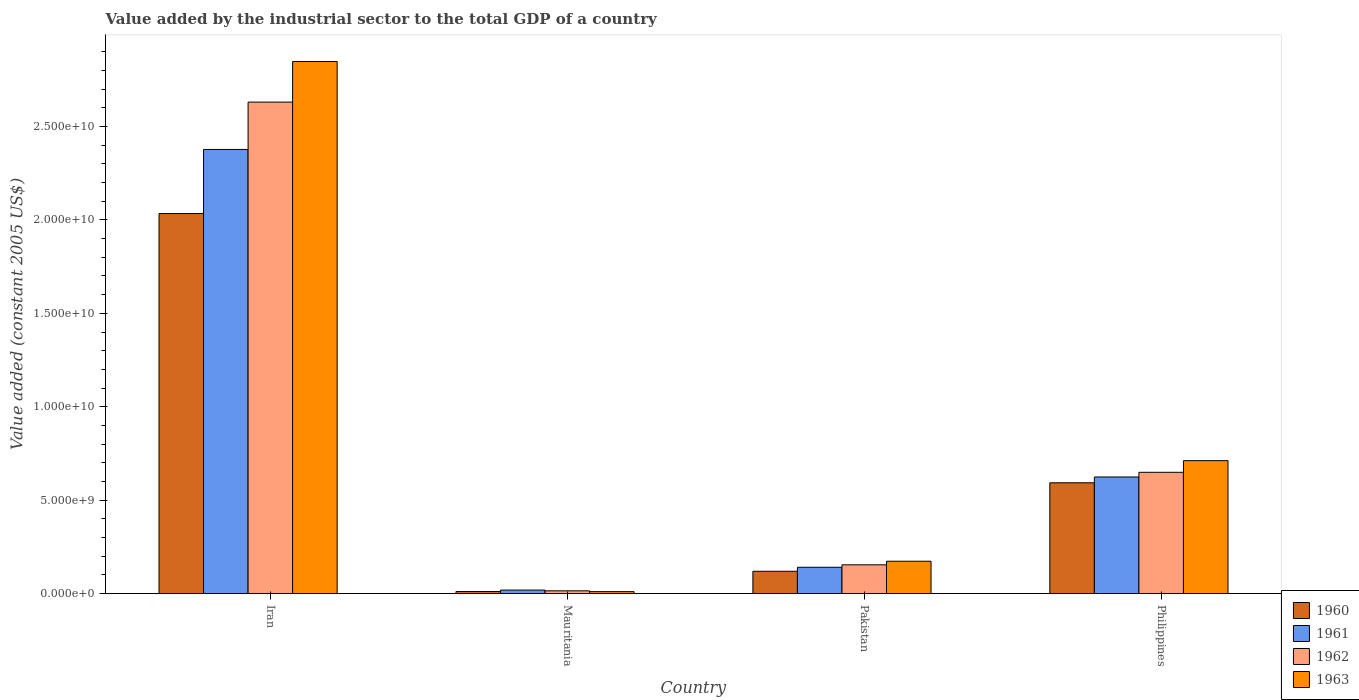How many different coloured bars are there?
Provide a succinct answer. 4. Are the number of bars per tick equal to the number of legend labels?
Offer a terse response. Yes. Are the number of bars on each tick of the X-axis equal?
Ensure brevity in your answer.  Yes. What is the label of the 1st group of bars from the left?
Give a very brief answer. Iran. In how many cases, is the number of bars for a given country not equal to the number of legend labels?
Offer a terse response. 0. What is the value added by the industrial sector in 1961 in Pakistan?
Ensure brevity in your answer.  1.41e+09. Across all countries, what is the maximum value added by the industrial sector in 1960?
Keep it short and to the point. 2.03e+1. Across all countries, what is the minimum value added by the industrial sector in 1961?
Your response must be concise. 1.92e+08. In which country was the value added by the industrial sector in 1963 maximum?
Offer a terse response. Iran. In which country was the value added by the industrial sector in 1961 minimum?
Offer a terse response. Mauritania. What is the total value added by the industrial sector in 1963 in the graph?
Provide a succinct answer. 3.74e+1. What is the difference between the value added by the industrial sector in 1960 in Iran and that in Pakistan?
Your response must be concise. 1.91e+1. What is the difference between the value added by the industrial sector in 1962 in Iran and the value added by the industrial sector in 1960 in Philippines?
Offer a terse response. 2.04e+1. What is the average value added by the industrial sector in 1961 per country?
Ensure brevity in your answer.  7.90e+09. What is the difference between the value added by the industrial sector of/in 1961 and value added by the industrial sector of/in 1963 in Mauritania?
Provide a succinct answer. 8.39e+07. In how many countries, is the value added by the industrial sector in 1961 greater than 9000000000 US$?
Provide a succinct answer. 1. What is the ratio of the value added by the industrial sector in 1962 in Iran to that in Pakistan?
Your response must be concise. 17.04. Is the value added by the industrial sector in 1963 in Mauritania less than that in Philippines?
Provide a short and direct response. Yes. What is the difference between the highest and the second highest value added by the industrial sector in 1962?
Make the answer very short. -1.98e+1. What is the difference between the highest and the lowest value added by the industrial sector in 1962?
Give a very brief answer. 2.62e+1. Is it the case that in every country, the sum of the value added by the industrial sector in 1962 and value added by the industrial sector in 1963 is greater than the sum of value added by the industrial sector in 1960 and value added by the industrial sector in 1961?
Offer a terse response. No. What does the 4th bar from the left in Philippines represents?
Your answer should be compact. 1963. How many bars are there?
Keep it short and to the point. 16. Are all the bars in the graph horizontal?
Provide a succinct answer. No. What is the difference between two consecutive major ticks on the Y-axis?
Keep it short and to the point. 5.00e+09. Does the graph contain any zero values?
Your answer should be compact. No. Does the graph contain grids?
Provide a succinct answer. No. Where does the legend appear in the graph?
Ensure brevity in your answer.  Bottom right. How many legend labels are there?
Your answer should be very brief. 4. What is the title of the graph?
Make the answer very short. Value added by the industrial sector to the total GDP of a country. What is the label or title of the Y-axis?
Give a very brief answer. Value added (constant 2005 US$). What is the Value added (constant 2005 US$) of 1960 in Iran?
Provide a short and direct response. 2.03e+1. What is the Value added (constant 2005 US$) in 1961 in Iran?
Your response must be concise. 2.38e+1. What is the Value added (constant 2005 US$) in 1962 in Iran?
Offer a very short reply. 2.63e+1. What is the Value added (constant 2005 US$) in 1963 in Iran?
Ensure brevity in your answer.  2.85e+1. What is the Value added (constant 2005 US$) of 1960 in Mauritania?
Offer a very short reply. 1.15e+08. What is the Value added (constant 2005 US$) in 1961 in Mauritania?
Provide a short and direct response. 1.92e+08. What is the Value added (constant 2005 US$) of 1962 in Mauritania?
Your response must be concise. 1.51e+08. What is the Value added (constant 2005 US$) of 1963 in Mauritania?
Provide a succinct answer. 1.08e+08. What is the Value added (constant 2005 US$) in 1960 in Pakistan?
Offer a very short reply. 1.20e+09. What is the Value added (constant 2005 US$) of 1961 in Pakistan?
Provide a succinct answer. 1.41e+09. What is the Value added (constant 2005 US$) of 1962 in Pakistan?
Your answer should be very brief. 1.54e+09. What is the Value added (constant 2005 US$) of 1963 in Pakistan?
Provide a succinct answer. 1.74e+09. What is the Value added (constant 2005 US$) in 1960 in Philippines?
Your answer should be very brief. 5.93e+09. What is the Value added (constant 2005 US$) of 1961 in Philippines?
Keep it short and to the point. 6.24e+09. What is the Value added (constant 2005 US$) of 1962 in Philippines?
Your answer should be compact. 6.49e+09. What is the Value added (constant 2005 US$) in 1963 in Philippines?
Keep it short and to the point. 7.12e+09. Across all countries, what is the maximum Value added (constant 2005 US$) in 1960?
Offer a very short reply. 2.03e+1. Across all countries, what is the maximum Value added (constant 2005 US$) in 1961?
Offer a very short reply. 2.38e+1. Across all countries, what is the maximum Value added (constant 2005 US$) of 1962?
Offer a very short reply. 2.63e+1. Across all countries, what is the maximum Value added (constant 2005 US$) in 1963?
Your answer should be very brief. 2.85e+1. Across all countries, what is the minimum Value added (constant 2005 US$) of 1960?
Provide a succinct answer. 1.15e+08. Across all countries, what is the minimum Value added (constant 2005 US$) of 1961?
Offer a very short reply. 1.92e+08. Across all countries, what is the minimum Value added (constant 2005 US$) of 1962?
Ensure brevity in your answer.  1.51e+08. Across all countries, what is the minimum Value added (constant 2005 US$) in 1963?
Make the answer very short. 1.08e+08. What is the total Value added (constant 2005 US$) in 1960 in the graph?
Provide a short and direct response. 2.76e+1. What is the total Value added (constant 2005 US$) in 1961 in the graph?
Your answer should be compact. 3.16e+1. What is the total Value added (constant 2005 US$) of 1962 in the graph?
Provide a short and direct response. 3.45e+1. What is the total Value added (constant 2005 US$) in 1963 in the graph?
Give a very brief answer. 3.74e+1. What is the difference between the Value added (constant 2005 US$) in 1960 in Iran and that in Mauritania?
Offer a very short reply. 2.02e+1. What is the difference between the Value added (constant 2005 US$) in 1961 in Iran and that in Mauritania?
Offer a very short reply. 2.36e+1. What is the difference between the Value added (constant 2005 US$) in 1962 in Iran and that in Mauritania?
Offer a terse response. 2.62e+1. What is the difference between the Value added (constant 2005 US$) of 1963 in Iran and that in Mauritania?
Your response must be concise. 2.84e+1. What is the difference between the Value added (constant 2005 US$) of 1960 in Iran and that in Pakistan?
Ensure brevity in your answer.  1.91e+1. What is the difference between the Value added (constant 2005 US$) of 1961 in Iran and that in Pakistan?
Your answer should be compact. 2.24e+1. What is the difference between the Value added (constant 2005 US$) of 1962 in Iran and that in Pakistan?
Ensure brevity in your answer.  2.48e+1. What is the difference between the Value added (constant 2005 US$) of 1963 in Iran and that in Pakistan?
Give a very brief answer. 2.67e+1. What is the difference between the Value added (constant 2005 US$) of 1960 in Iran and that in Philippines?
Make the answer very short. 1.44e+1. What is the difference between the Value added (constant 2005 US$) of 1961 in Iran and that in Philippines?
Offer a terse response. 1.75e+1. What is the difference between the Value added (constant 2005 US$) in 1962 in Iran and that in Philippines?
Give a very brief answer. 1.98e+1. What is the difference between the Value added (constant 2005 US$) of 1963 in Iran and that in Philippines?
Your answer should be compact. 2.14e+1. What is the difference between the Value added (constant 2005 US$) of 1960 in Mauritania and that in Pakistan?
Offer a very short reply. -1.08e+09. What is the difference between the Value added (constant 2005 US$) in 1961 in Mauritania and that in Pakistan?
Your answer should be very brief. -1.22e+09. What is the difference between the Value added (constant 2005 US$) in 1962 in Mauritania and that in Pakistan?
Your answer should be compact. -1.39e+09. What is the difference between the Value added (constant 2005 US$) of 1963 in Mauritania and that in Pakistan?
Your answer should be compact. -1.63e+09. What is the difference between the Value added (constant 2005 US$) in 1960 in Mauritania and that in Philippines?
Offer a terse response. -5.82e+09. What is the difference between the Value added (constant 2005 US$) in 1961 in Mauritania and that in Philippines?
Your answer should be very brief. -6.05e+09. What is the difference between the Value added (constant 2005 US$) in 1962 in Mauritania and that in Philippines?
Your response must be concise. -6.34e+09. What is the difference between the Value added (constant 2005 US$) in 1963 in Mauritania and that in Philippines?
Keep it short and to the point. -7.01e+09. What is the difference between the Value added (constant 2005 US$) in 1960 in Pakistan and that in Philippines?
Offer a terse response. -4.73e+09. What is the difference between the Value added (constant 2005 US$) in 1961 in Pakistan and that in Philippines?
Offer a very short reply. -4.83e+09. What is the difference between the Value added (constant 2005 US$) in 1962 in Pakistan and that in Philippines?
Ensure brevity in your answer.  -4.95e+09. What is the difference between the Value added (constant 2005 US$) of 1963 in Pakistan and that in Philippines?
Give a very brief answer. -5.38e+09. What is the difference between the Value added (constant 2005 US$) in 1960 in Iran and the Value added (constant 2005 US$) in 1961 in Mauritania?
Provide a short and direct response. 2.01e+1. What is the difference between the Value added (constant 2005 US$) in 1960 in Iran and the Value added (constant 2005 US$) in 1962 in Mauritania?
Provide a short and direct response. 2.02e+1. What is the difference between the Value added (constant 2005 US$) of 1960 in Iran and the Value added (constant 2005 US$) of 1963 in Mauritania?
Provide a short and direct response. 2.02e+1. What is the difference between the Value added (constant 2005 US$) in 1961 in Iran and the Value added (constant 2005 US$) in 1962 in Mauritania?
Provide a short and direct response. 2.36e+1. What is the difference between the Value added (constant 2005 US$) in 1961 in Iran and the Value added (constant 2005 US$) in 1963 in Mauritania?
Give a very brief answer. 2.37e+1. What is the difference between the Value added (constant 2005 US$) in 1962 in Iran and the Value added (constant 2005 US$) in 1963 in Mauritania?
Provide a succinct answer. 2.62e+1. What is the difference between the Value added (constant 2005 US$) in 1960 in Iran and the Value added (constant 2005 US$) in 1961 in Pakistan?
Ensure brevity in your answer.  1.89e+1. What is the difference between the Value added (constant 2005 US$) in 1960 in Iran and the Value added (constant 2005 US$) in 1962 in Pakistan?
Keep it short and to the point. 1.88e+1. What is the difference between the Value added (constant 2005 US$) of 1960 in Iran and the Value added (constant 2005 US$) of 1963 in Pakistan?
Your answer should be compact. 1.86e+1. What is the difference between the Value added (constant 2005 US$) of 1961 in Iran and the Value added (constant 2005 US$) of 1962 in Pakistan?
Your response must be concise. 2.22e+1. What is the difference between the Value added (constant 2005 US$) of 1961 in Iran and the Value added (constant 2005 US$) of 1963 in Pakistan?
Keep it short and to the point. 2.20e+1. What is the difference between the Value added (constant 2005 US$) in 1962 in Iran and the Value added (constant 2005 US$) in 1963 in Pakistan?
Provide a short and direct response. 2.46e+1. What is the difference between the Value added (constant 2005 US$) in 1960 in Iran and the Value added (constant 2005 US$) in 1961 in Philippines?
Offer a terse response. 1.41e+1. What is the difference between the Value added (constant 2005 US$) in 1960 in Iran and the Value added (constant 2005 US$) in 1962 in Philippines?
Your response must be concise. 1.38e+1. What is the difference between the Value added (constant 2005 US$) in 1960 in Iran and the Value added (constant 2005 US$) in 1963 in Philippines?
Your answer should be compact. 1.32e+1. What is the difference between the Value added (constant 2005 US$) in 1961 in Iran and the Value added (constant 2005 US$) in 1962 in Philippines?
Keep it short and to the point. 1.73e+1. What is the difference between the Value added (constant 2005 US$) of 1961 in Iran and the Value added (constant 2005 US$) of 1963 in Philippines?
Offer a very short reply. 1.67e+1. What is the difference between the Value added (constant 2005 US$) in 1962 in Iran and the Value added (constant 2005 US$) in 1963 in Philippines?
Ensure brevity in your answer.  1.92e+1. What is the difference between the Value added (constant 2005 US$) of 1960 in Mauritania and the Value added (constant 2005 US$) of 1961 in Pakistan?
Your answer should be compact. -1.30e+09. What is the difference between the Value added (constant 2005 US$) in 1960 in Mauritania and the Value added (constant 2005 US$) in 1962 in Pakistan?
Ensure brevity in your answer.  -1.43e+09. What is the difference between the Value added (constant 2005 US$) of 1960 in Mauritania and the Value added (constant 2005 US$) of 1963 in Pakistan?
Your answer should be compact. -1.62e+09. What is the difference between the Value added (constant 2005 US$) of 1961 in Mauritania and the Value added (constant 2005 US$) of 1962 in Pakistan?
Ensure brevity in your answer.  -1.35e+09. What is the difference between the Value added (constant 2005 US$) of 1961 in Mauritania and the Value added (constant 2005 US$) of 1963 in Pakistan?
Your answer should be compact. -1.54e+09. What is the difference between the Value added (constant 2005 US$) in 1962 in Mauritania and the Value added (constant 2005 US$) in 1963 in Pakistan?
Make the answer very short. -1.58e+09. What is the difference between the Value added (constant 2005 US$) in 1960 in Mauritania and the Value added (constant 2005 US$) in 1961 in Philippines?
Make the answer very short. -6.13e+09. What is the difference between the Value added (constant 2005 US$) of 1960 in Mauritania and the Value added (constant 2005 US$) of 1962 in Philippines?
Provide a succinct answer. -6.38e+09. What is the difference between the Value added (constant 2005 US$) of 1960 in Mauritania and the Value added (constant 2005 US$) of 1963 in Philippines?
Provide a succinct answer. -7.00e+09. What is the difference between the Value added (constant 2005 US$) of 1961 in Mauritania and the Value added (constant 2005 US$) of 1962 in Philippines?
Your answer should be very brief. -6.30e+09. What is the difference between the Value added (constant 2005 US$) of 1961 in Mauritania and the Value added (constant 2005 US$) of 1963 in Philippines?
Make the answer very short. -6.93e+09. What is the difference between the Value added (constant 2005 US$) of 1962 in Mauritania and the Value added (constant 2005 US$) of 1963 in Philippines?
Ensure brevity in your answer.  -6.97e+09. What is the difference between the Value added (constant 2005 US$) of 1960 in Pakistan and the Value added (constant 2005 US$) of 1961 in Philippines?
Provide a succinct answer. -5.05e+09. What is the difference between the Value added (constant 2005 US$) in 1960 in Pakistan and the Value added (constant 2005 US$) in 1962 in Philippines?
Your answer should be compact. -5.30e+09. What is the difference between the Value added (constant 2005 US$) in 1960 in Pakistan and the Value added (constant 2005 US$) in 1963 in Philippines?
Your answer should be compact. -5.92e+09. What is the difference between the Value added (constant 2005 US$) of 1961 in Pakistan and the Value added (constant 2005 US$) of 1962 in Philippines?
Make the answer very short. -5.08e+09. What is the difference between the Value added (constant 2005 US$) in 1961 in Pakistan and the Value added (constant 2005 US$) in 1963 in Philippines?
Give a very brief answer. -5.71e+09. What is the difference between the Value added (constant 2005 US$) in 1962 in Pakistan and the Value added (constant 2005 US$) in 1963 in Philippines?
Offer a very short reply. -5.57e+09. What is the average Value added (constant 2005 US$) in 1960 per country?
Keep it short and to the point. 6.90e+09. What is the average Value added (constant 2005 US$) of 1961 per country?
Provide a succinct answer. 7.90e+09. What is the average Value added (constant 2005 US$) in 1962 per country?
Give a very brief answer. 8.62e+09. What is the average Value added (constant 2005 US$) in 1963 per country?
Ensure brevity in your answer.  9.36e+09. What is the difference between the Value added (constant 2005 US$) in 1960 and Value added (constant 2005 US$) in 1961 in Iran?
Give a very brief answer. -3.43e+09. What is the difference between the Value added (constant 2005 US$) in 1960 and Value added (constant 2005 US$) in 1962 in Iran?
Give a very brief answer. -5.96e+09. What is the difference between the Value added (constant 2005 US$) of 1960 and Value added (constant 2005 US$) of 1963 in Iran?
Your answer should be compact. -8.14e+09. What is the difference between the Value added (constant 2005 US$) of 1961 and Value added (constant 2005 US$) of 1962 in Iran?
Your response must be concise. -2.53e+09. What is the difference between the Value added (constant 2005 US$) of 1961 and Value added (constant 2005 US$) of 1963 in Iran?
Offer a terse response. -4.71e+09. What is the difference between the Value added (constant 2005 US$) in 1962 and Value added (constant 2005 US$) in 1963 in Iran?
Keep it short and to the point. -2.17e+09. What is the difference between the Value added (constant 2005 US$) in 1960 and Value added (constant 2005 US$) in 1961 in Mauritania?
Keep it short and to the point. -7.68e+07. What is the difference between the Value added (constant 2005 US$) of 1960 and Value added (constant 2005 US$) of 1962 in Mauritania?
Ensure brevity in your answer.  -3.59e+07. What is the difference between the Value added (constant 2005 US$) of 1960 and Value added (constant 2005 US$) of 1963 in Mauritania?
Your response must be concise. 7.13e+06. What is the difference between the Value added (constant 2005 US$) in 1961 and Value added (constant 2005 US$) in 1962 in Mauritania?
Ensure brevity in your answer.  4.09e+07. What is the difference between the Value added (constant 2005 US$) of 1961 and Value added (constant 2005 US$) of 1963 in Mauritania?
Provide a succinct answer. 8.39e+07. What is the difference between the Value added (constant 2005 US$) of 1962 and Value added (constant 2005 US$) of 1963 in Mauritania?
Offer a terse response. 4.31e+07. What is the difference between the Value added (constant 2005 US$) in 1960 and Value added (constant 2005 US$) in 1961 in Pakistan?
Offer a terse response. -2.14e+08. What is the difference between the Value added (constant 2005 US$) in 1960 and Value added (constant 2005 US$) in 1962 in Pakistan?
Keep it short and to the point. -3.45e+08. What is the difference between the Value added (constant 2005 US$) of 1960 and Value added (constant 2005 US$) of 1963 in Pakistan?
Keep it short and to the point. -5.37e+08. What is the difference between the Value added (constant 2005 US$) in 1961 and Value added (constant 2005 US$) in 1962 in Pakistan?
Your answer should be very brief. -1.32e+08. What is the difference between the Value added (constant 2005 US$) in 1961 and Value added (constant 2005 US$) in 1963 in Pakistan?
Give a very brief answer. -3.23e+08. What is the difference between the Value added (constant 2005 US$) in 1962 and Value added (constant 2005 US$) in 1963 in Pakistan?
Your answer should be compact. -1.92e+08. What is the difference between the Value added (constant 2005 US$) in 1960 and Value added (constant 2005 US$) in 1961 in Philippines?
Your answer should be compact. -3.11e+08. What is the difference between the Value added (constant 2005 US$) in 1960 and Value added (constant 2005 US$) in 1962 in Philippines?
Your response must be concise. -5.61e+08. What is the difference between the Value added (constant 2005 US$) of 1960 and Value added (constant 2005 US$) of 1963 in Philippines?
Keep it short and to the point. -1.18e+09. What is the difference between the Value added (constant 2005 US$) in 1961 and Value added (constant 2005 US$) in 1962 in Philippines?
Provide a short and direct response. -2.50e+08. What is the difference between the Value added (constant 2005 US$) in 1961 and Value added (constant 2005 US$) in 1963 in Philippines?
Provide a succinct answer. -8.74e+08. What is the difference between the Value added (constant 2005 US$) in 1962 and Value added (constant 2005 US$) in 1963 in Philippines?
Your answer should be very brief. -6.24e+08. What is the ratio of the Value added (constant 2005 US$) in 1960 in Iran to that in Mauritania?
Keep it short and to the point. 176.32. What is the ratio of the Value added (constant 2005 US$) in 1961 in Iran to that in Mauritania?
Keep it short and to the point. 123.7. What is the ratio of the Value added (constant 2005 US$) in 1962 in Iran to that in Mauritania?
Offer a very short reply. 173.84. What is the ratio of the Value added (constant 2005 US$) of 1963 in Iran to that in Mauritania?
Ensure brevity in your answer.  263.11. What is the ratio of the Value added (constant 2005 US$) in 1960 in Iran to that in Pakistan?
Provide a succinct answer. 16.98. What is the ratio of the Value added (constant 2005 US$) in 1961 in Iran to that in Pakistan?
Give a very brief answer. 16.84. What is the ratio of the Value added (constant 2005 US$) in 1962 in Iran to that in Pakistan?
Your answer should be compact. 17.04. What is the ratio of the Value added (constant 2005 US$) in 1963 in Iran to that in Pakistan?
Your answer should be very brief. 16.41. What is the ratio of the Value added (constant 2005 US$) of 1960 in Iran to that in Philippines?
Ensure brevity in your answer.  3.43. What is the ratio of the Value added (constant 2005 US$) in 1961 in Iran to that in Philippines?
Ensure brevity in your answer.  3.81. What is the ratio of the Value added (constant 2005 US$) in 1962 in Iran to that in Philippines?
Offer a terse response. 4.05. What is the ratio of the Value added (constant 2005 US$) in 1963 in Iran to that in Philippines?
Your answer should be very brief. 4. What is the ratio of the Value added (constant 2005 US$) of 1960 in Mauritania to that in Pakistan?
Keep it short and to the point. 0.1. What is the ratio of the Value added (constant 2005 US$) of 1961 in Mauritania to that in Pakistan?
Provide a succinct answer. 0.14. What is the ratio of the Value added (constant 2005 US$) of 1962 in Mauritania to that in Pakistan?
Provide a succinct answer. 0.1. What is the ratio of the Value added (constant 2005 US$) in 1963 in Mauritania to that in Pakistan?
Provide a succinct answer. 0.06. What is the ratio of the Value added (constant 2005 US$) of 1960 in Mauritania to that in Philippines?
Make the answer very short. 0.02. What is the ratio of the Value added (constant 2005 US$) in 1961 in Mauritania to that in Philippines?
Make the answer very short. 0.03. What is the ratio of the Value added (constant 2005 US$) of 1962 in Mauritania to that in Philippines?
Provide a succinct answer. 0.02. What is the ratio of the Value added (constant 2005 US$) in 1963 in Mauritania to that in Philippines?
Your answer should be compact. 0.02. What is the ratio of the Value added (constant 2005 US$) in 1960 in Pakistan to that in Philippines?
Your answer should be compact. 0.2. What is the ratio of the Value added (constant 2005 US$) in 1961 in Pakistan to that in Philippines?
Keep it short and to the point. 0.23. What is the ratio of the Value added (constant 2005 US$) in 1962 in Pakistan to that in Philippines?
Your answer should be very brief. 0.24. What is the ratio of the Value added (constant 2005 US$) of 1963 in Pakistan to that in Philippines?
Give a very brief answer. 0.24. What is the difference between the highest and the second highest Value added (constant 2005 US$) of 1960?
Offer a terse response. 1.44e+1. What is the difference between the highest and the second highest Value added (constant 2005 US$) in 1961?
Provide a succinct answer. 1.75e+1. What is the difference between the highest and the second highest Value added (constant 2005 US$) of 1962?
Offer a terse response. 1.98e+1. What is the difference between the highest and the second highest Value added (constant 2005 US$) in 1963?
Keep it short and to the point. 2.14e+1. What is the difference between the highest and the lowest Value added (constant 2005 US$) of 1960?
Your response must be concise. 2.02e+1. What is the difference between the highest and the lowest Value added (constant 2005 US$) in 1961?
Offer a very short reply. 2.36e+1. What is the difference between the highest and the lowest Value added (constant 2005 US$) of 1962?
Your answer should be very brief. 2.62e+1. What is the difference between the highest and the lowest Value added (constant 2005 US$) of 1963?
Provide a short and direct response. 2.84e+1. 